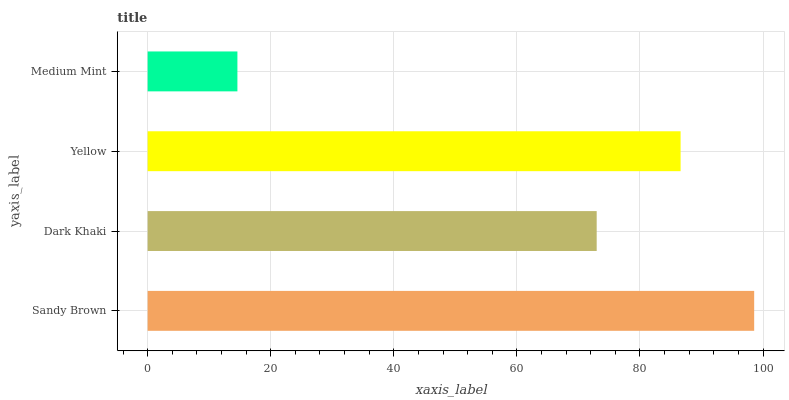Is Medium Mint the minimum?
Answer yes or no. Yes. Is Sandy Brown the maximum?
Answer yes or no. Yes. Is Dark Khaki the minimum?
Answer yes or no. No. Is Dark Khaki the maximum?
Answer yes or no. No. Is Sandy Brown greater than Dark Khaki?
Answer yes or no. Yes. Is Dark Khaki less than Sandy Brown?
Answer yes or no. Yes. Is Dark Khaki greater than Sandy Brown?
Answer yes or no. No. Is Sandy Brown less than Dark Khaki?
Answer yes or no. No. Is Yellow the high median?
Answer yes or no. Yes. Is Dark Khaki the low median?
Answer yes or no. Yes. Is Dark Khaki the high median?
Answer yes or no. No. Is Medium Mint the low median?
Answer yes or no. No. 